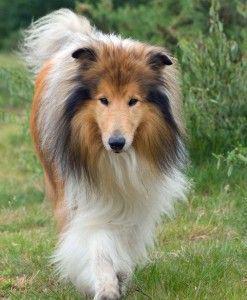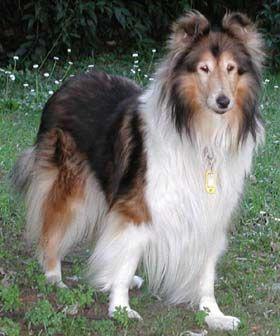The first image is the image on the left, the second image is the image on the right. For the images shown, is this caption "In 1 of the images, 1 dog has an open mouth." true? Answer yes or no. No. 